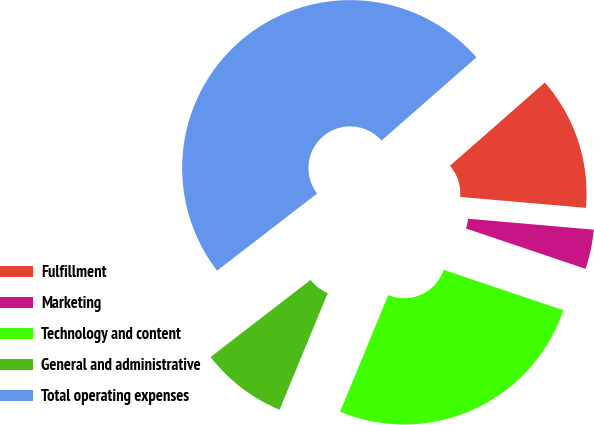Convert chart. <chart><loc_0><loc_0><loc_500><loc_500><pie_chart><fcel>Fulfillment<fcel>Marketing<fcel>Technology and content<fcel>General and administrative<fcel>Total operating expenses<nl><fcel>12.84%<fcel>3.8%<fcel>26.05%<fcel>8.32%<fcel>48.99%<nl></chart> 